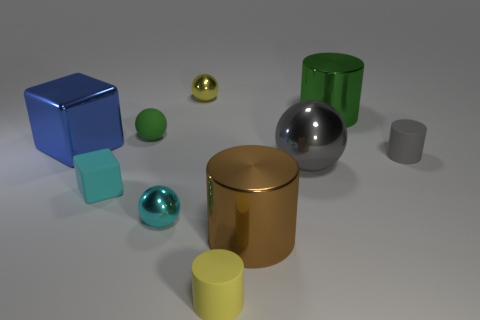Subtract all matte spheres. How many spheres are left? 3 Subtract all green spheres. How many spheres are left? 3 Subtract 2 spheres. How many spheres are left? 2 Subtract all cylinders. How many objects are left? 6 Subtract all red cylinders. Subtract all blue spheres. How many cylinders are left? 4 Subtract all red metal balls. Subtract all gray cylinders. How many objects are left? 9 Add 4 gray rubber cylinders. How many gray rubber cylinders are left? 5 Add 6 purple things. How many purple things exist? 6 Subtract 1 brown cylinders. How many objects are left? 9 